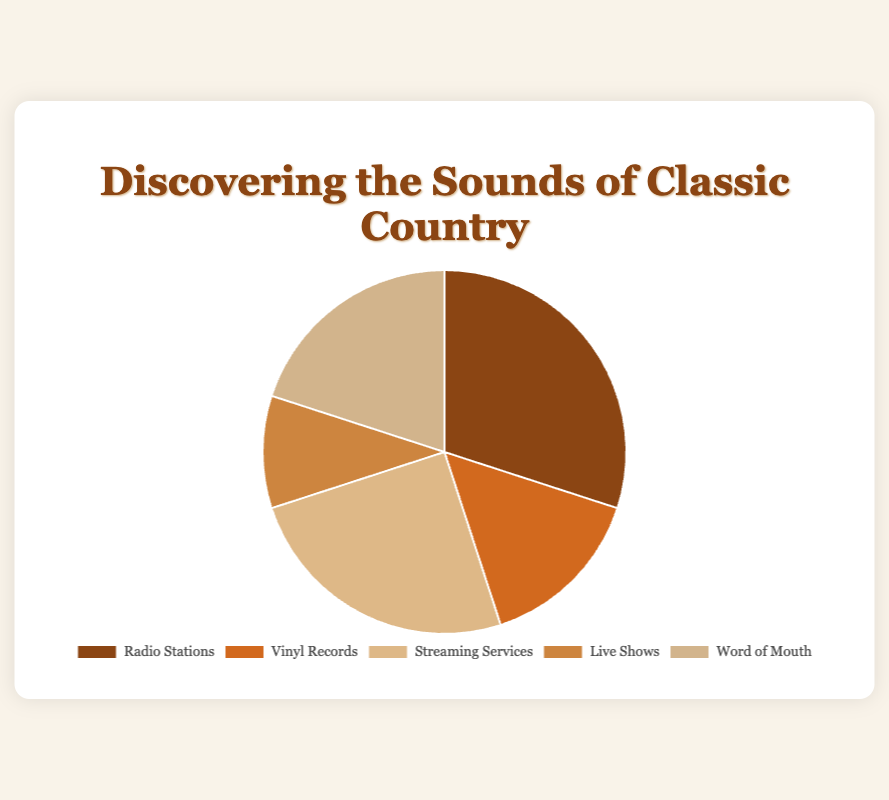Which music discovery source has the highest percentage? The pie chart shows the different sources of music discovery for classic country fans, with Radio Stations having the largest section.
Answer: Radio Stations What is the combined percentage of Vinyl Records and Word of Mouth? The pie chart shows percentages for each source, with Vinyl Records at 15% and Word of Mouth at 20%. Adding these together, 15% + 20% = 35%.
Answer: 35% How does the percentage of Streaming Services compare to Live Shows? The pie chart displays Streaming Services at 25% and Live Shows at 10%. Streaming Services have a higher percentage.
Answer: Streaming Services are higher Which source has the smallest segment in the pie chart? The smallest segment of the pie chart represents Live Shows, with 10%.
Answer: Live Shows If we combine Radio Stations, Streaming Services, and Live Shows, what percentage do we get? The pie chart shows Radio Stations at 30%, Streaming Services at 25%, and Live Shows at 10%. Adding these together, 30% + 25% + 10% = 65%.
Answer: 65% What percentage of people discover classic country music through Streaming Services and Word of Mouth combined? The pie chart displays Streaming Services at 25% and Word of Mouth at 20%. Adding these together, 25% + 20% = 45%.
Answer: 45% Are there more classic country fans discovering music through Radio Stations or Word of Mouth? The pie chart shows Radio Stations at 30% and Word of Mouth at 20%. Radio Stations have a higher percentage.
Answer: Radio Stations Which slice of the pie chart is represented by the color red? The pie chart uses specific colors for each source of music discovery, with Live Shows being depicted in red.
Answer: Live Shows What is the difference in percentage between Radio Stations and Vinyl Records? The pie chart shows Radio Stations at 30% and Vinyl Records at 15%. The difference between them is 30% - 15% = 15%.
Answer: 15% What is the total percentage represented by sources other than Radio Stations? The pie chart shows Radio Stations at 30%, meaning the other sources combine to 100% - 30% = 70%.
Answer: 70% 